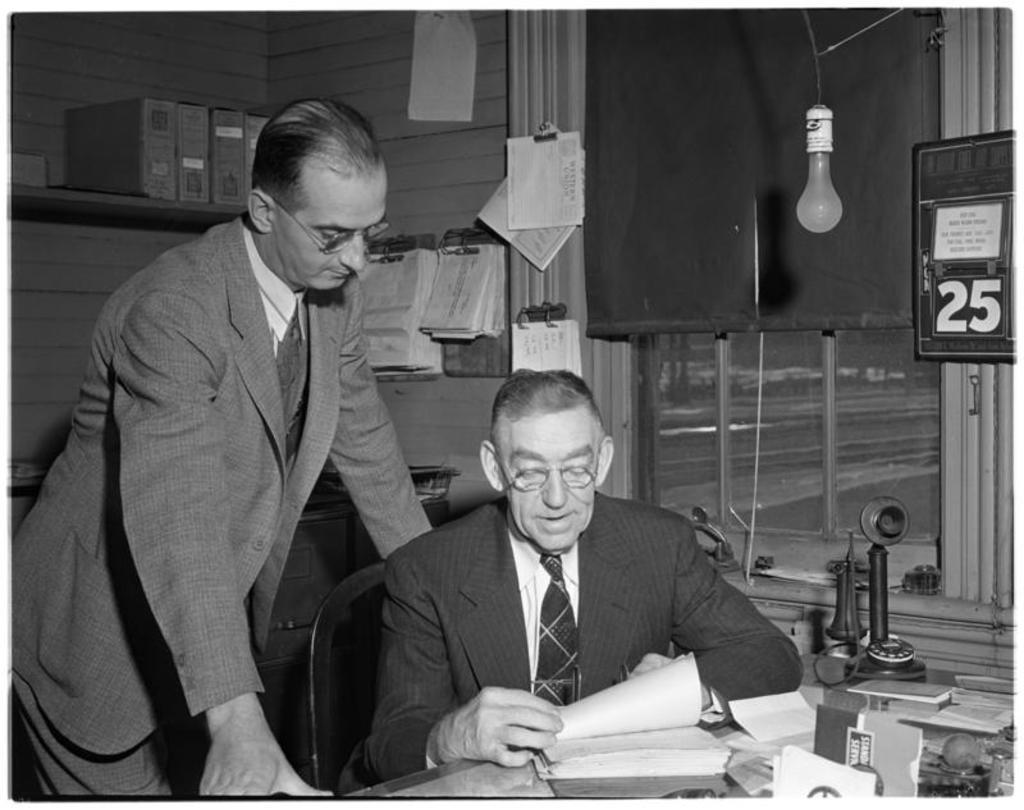Describe this image in one or two sentences. This is a black and white image. There are two persons in the image. There is a table on which there are many objects. There is a window. In the background of the image there is a wall. There is a shelf. 